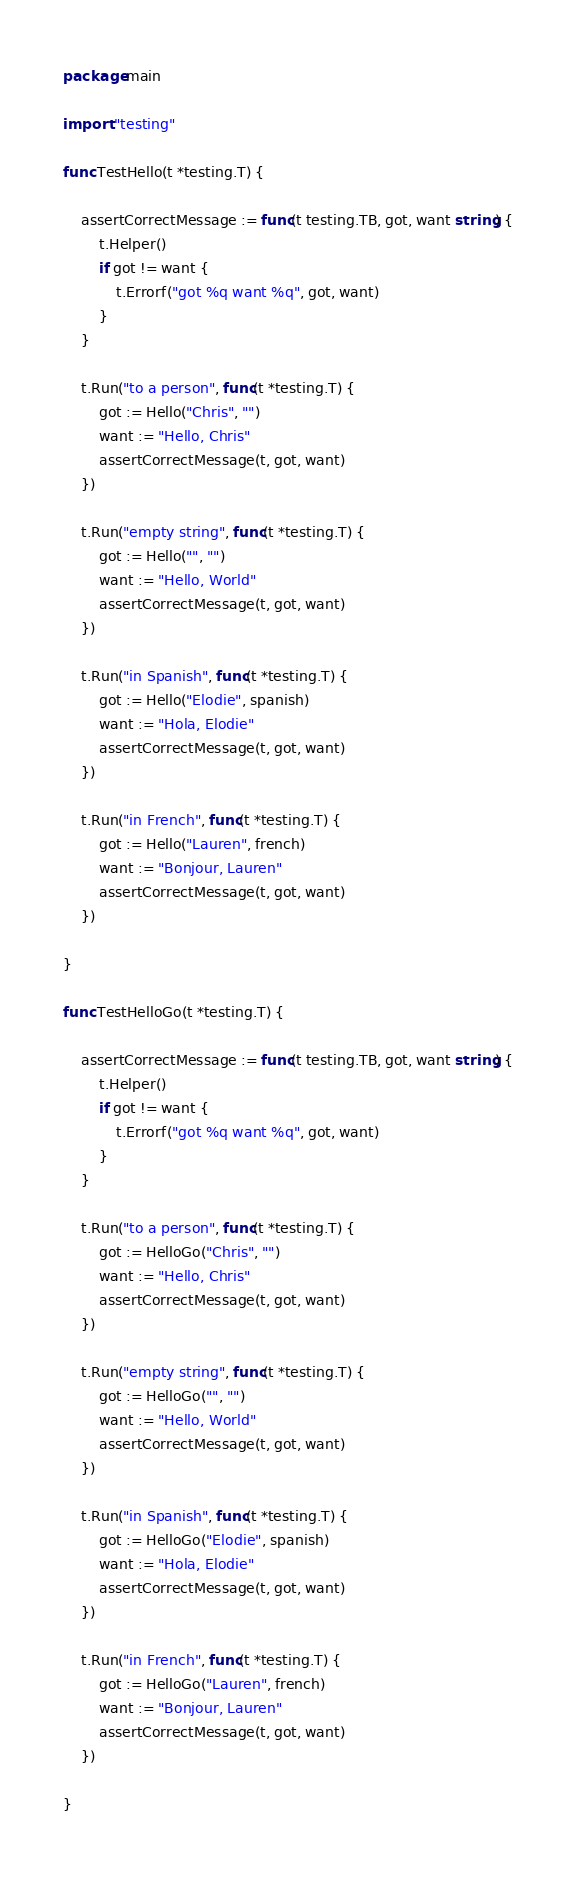<code> <loc_0><loc_0><loc_500><loc_500><_Go_>package main

import "testing"

func TestHello(t *testing.T) {

	assertCorrectMessage := func(t testing.TB, got, want string) {
		t.Helper()
		if got != want {
			t.Errorf("got %q want %q", got, want)
		}
	}

	t.Run("to a person", func(t *testing.T) {
		got := Hello("Chris", "")
		want := "Hello, Chris"
		assertCorrectMessage(t, got, want)
	})

	t.Run("empty string", func(t *testing.T) {
		got := Hello("", "")
		want := "Hello, World"
		assertCorrectMessage(t, got, want)
	})

	t.Run("in Spanish", func(t *testing.T) {
		got := Hello("Elodie", spanish)
		want := "Hola, Elodie"
		assertCorrectMessage(t, got, want)
	})

	t.Run("in French", func(t *testing.T) {
		got := Hello("Lauren", french)
		want := "Bonjour, Lauren"
		assertCorrectMessage(t, got, want)
	})

}

func TestHelloGo(t *testing.T) {

	assertCorrectMessage := func(t testing.TB, got, want string) {
		t.Helper()
		if got != want {
			t.Errorf("got %q want %q", got, want)
		}
	}

	t.Run("to a person", func(t *testing.T) {
		got := HelloGo("Chris", "")
		want := "Hello, Chris"
		assertCorrectMessage(t, got, want)
	})

	t.Run("empty string", func(t *testing.T) {
		got := HelloGo("", "")
		want := "Hello, World"
		assertCorrectMessage(t, got, want)
	})

	t.Run("in Spanish", func(t *testing.T) {
		got := HelloGo("Elodie", spanish)
		want := "Hola, Elodie"
		assertCorrectMessage(t, got, want)
	})

	t.Run("in French", func(t *testing.T) {
		got := HelloGo("Lauren", french)
		want := "Bonjour, Lauren"
		assertCorrectMessage(t, got, want)
	})

}
</code> 